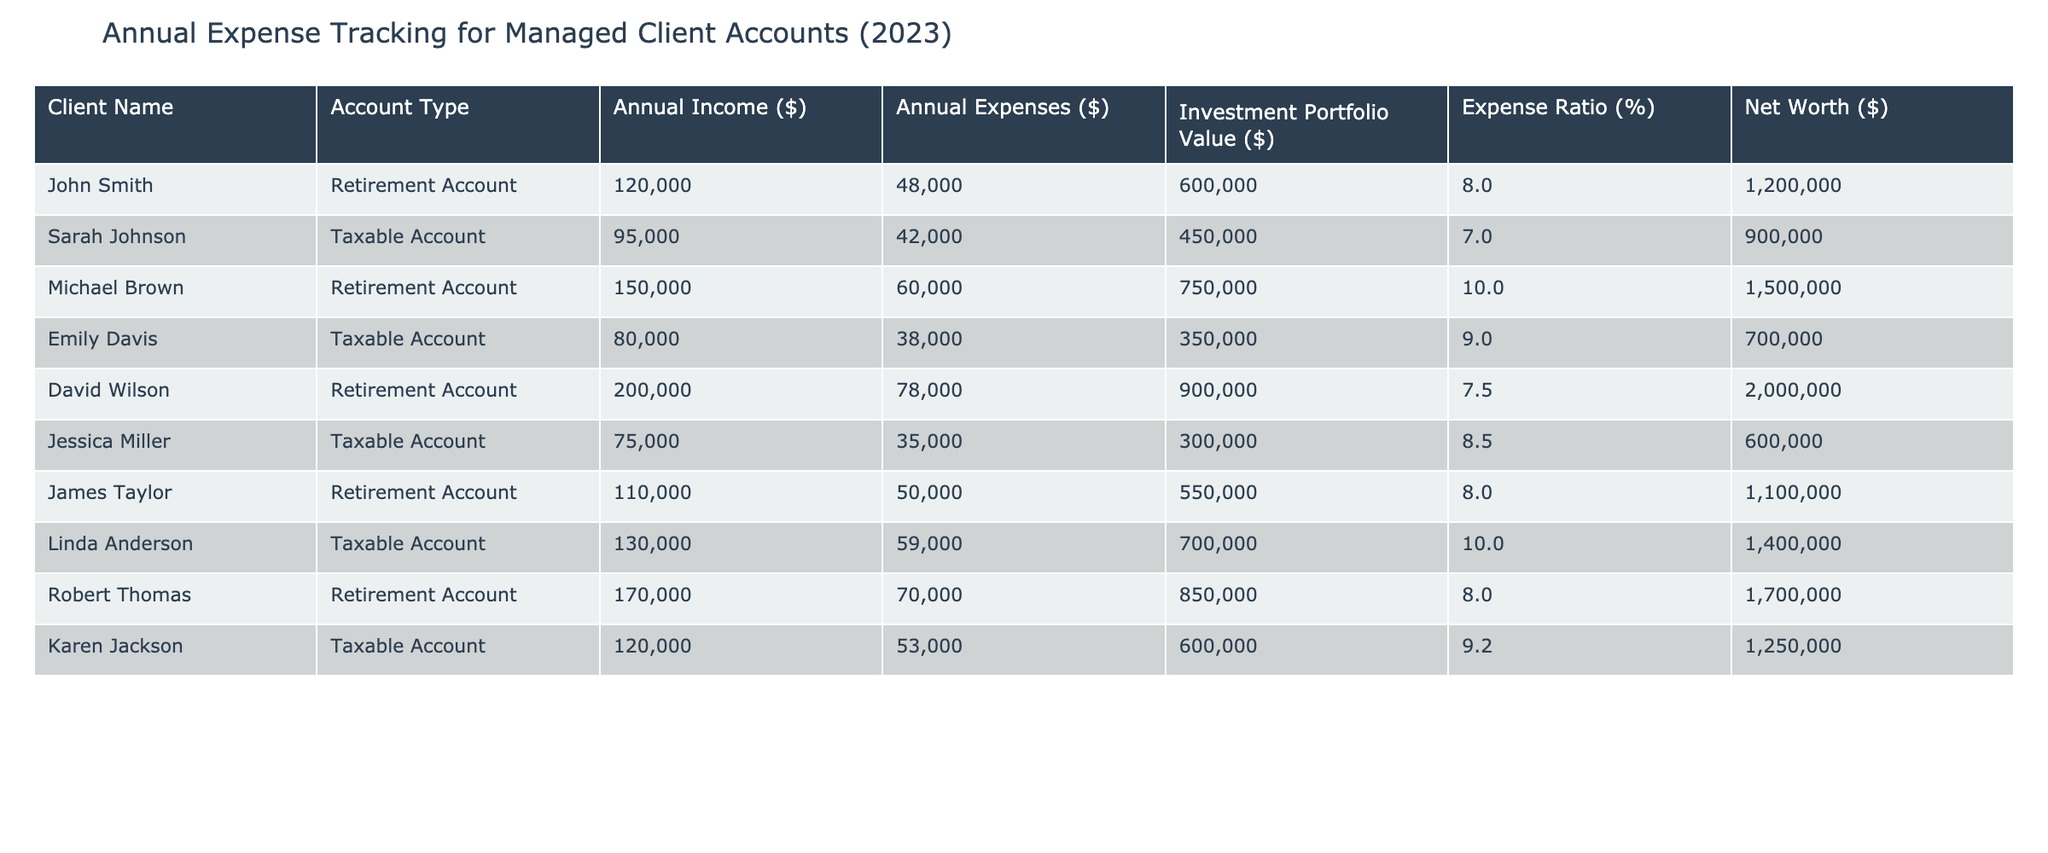What is the annual income of Linda Anderson? To find Linda Anderson's annual income, we look at her row in the table. The "Annual Income ($)" column shows that her income is $130,000.
Answer: $130,000 What is the total annual expense for all clients? To find the total annual expenses, we sum all the values in the "Annual Expenses ($)" column: 48,000 + 42,000 + 60,000 + 38,000 + 78,000 + 35,000 + 50,000 + 59,000 + 70,000 + 53,000 =  463,000.
Answer: $463,000 Is there any client who has an expense ratio of 10%? Checking the "Expense Ratio (%)" column, we find that Michael Brown and Linda Anderson both have an expense ratio of 10%. Thus, there are clients with this ratio.
Answer: Yes Who has the highest annual expenses? To determine who has the highest annual expenses, we look through the "Annual Expenses ($)" column for the maximum value. David Wilson has the highest expenses at $78,000.
Answer: David Wilson What is the average net worth of clients with a Taxable Account? For Taxable Accounts, we add the net worths: 900,000 + 600,000 + 1,400,000 + 1,250,000 = 4,150,000. There are 4 Taxable Account clients, so the average is 4,150,000 / 4 = 1,037,500.
Answer: $1,037,500 Which client has an investment portfolio value greater than $800,000? Checking the "Investment Portfolio Value ($)" column, we find that David Wilson, Robert Thomas, and Michael Brown have values greater than $800,000 (900,000, 850,000, and 750,000 respectively). Therefore, there are multiple clients with such a value.
Answer: David Wilson and Robert Thomas How much more does James Taylor earn compared to Emily Davis? We subtract Emily Davis's annual income from James Taylor's: 110,000 - 80,000 = 30,000. Thus, James Taylor earns $30,000 more than Emily Davis.
Answer: $30,000 What is the median annual expense across all clients? To find the median, we first list the annual expenses in order: 35,000, 38,000, 42,000, 48,000, 50,000, 53,000, 60,000, 70,000, 78,000. Since there are 10 values, the median is the average of the 5th and 6th values: (50,000 + 53,000) / 2 = 51,500.
Answer: $51,500 How many clients have an annual income below $100,000? We count the annual incomes that are below $100,000: John Smith, Sarah Johnson, Emily Davis, and Jessica Miller, totaling 4 clients.
Answer: 4 Is the expense ratio of David Wilson lower than that of Michael Brown? Comparing the "Expense Ratio (%)" column, David Wilson has 7.5% while Michael Brown has 10%. Thus, David Wilson's expense ratio is lower.
Answer: Yes 